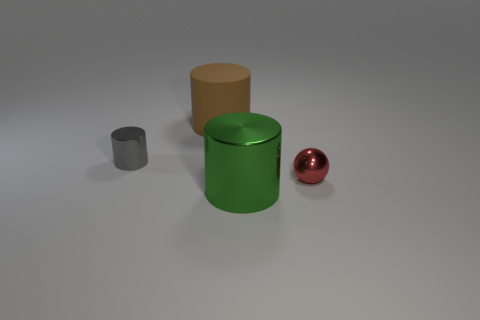How many large things are rubber cylinders or green metal cylinders?
Provide a short and direct response. 2. There is a thing behind the small gray cylinder; does it have the same color as the big cylinder that is right of the big brown rubber thing?
Give a very brief answer. No. How many other things are the same color as the large metallic cylinder?
Provide a succinct answer. 0. How many green things are either big metallic cylinders or large objects?
Ensure brevity in your answer.  1. There is a small red shiny object; is its shape the same as the tiny shiny thing to the left of the tiny sphere?
Your answer should be compact. No. What is the shape of the tiny gray object?
Provide a succinct answer. Cylinder. There is a thing that is the same size as the red ball; what is it made of?
Provide a short and direct response. Metal. Is there any other thing that has the same size as the matte cylinder?
Keep it short and to the point. Yes. How many objects are balls or small things to the right of the large brown matte cylinder?
Provide a short and direct response. 1. What size is the gray cylinder that is the same material as the tiny red thing?
Your response must be concise. Small. 